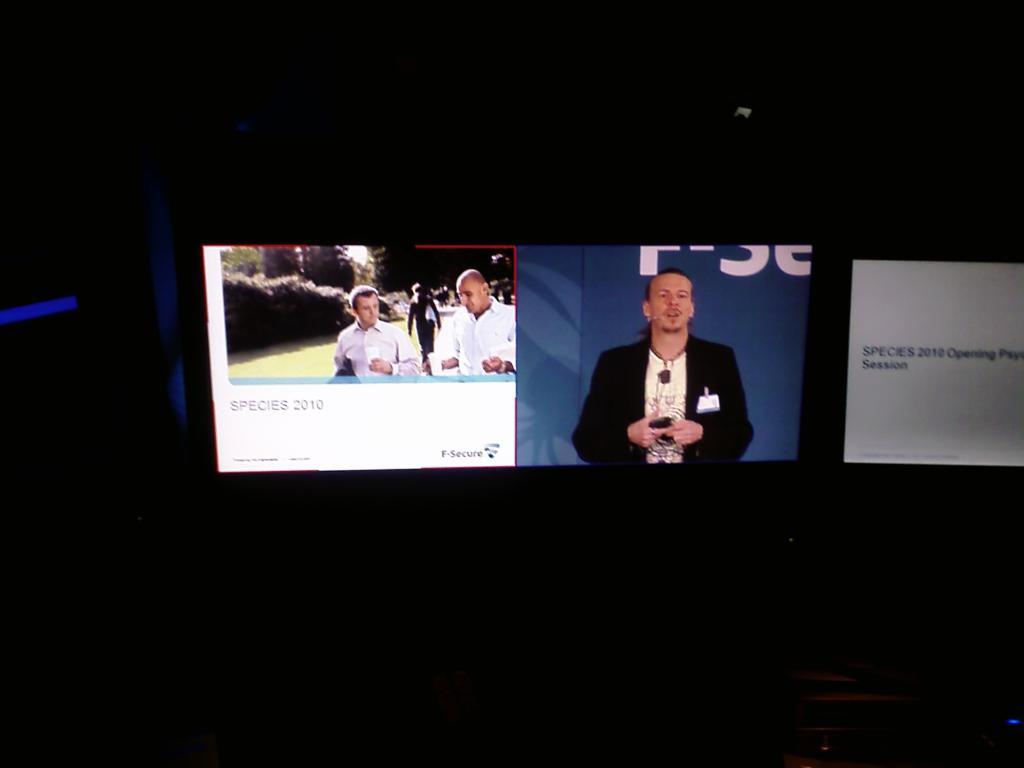<image>
Share a concise interpretation of the image provided. Three Species 2010 images are on different screens in the dark. 